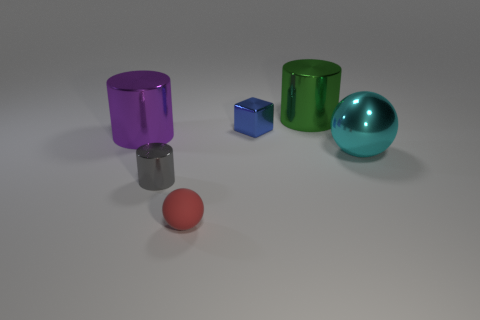Subtract all yellow spheres. Subtract all yellow blocks. How many spheres are left? 2 Add 4 purple cubes. How many objects exist? 10 Subtract all cubes. How many objects are left? 5 Subtract all big blue matte balls. Subtract all purple cylinders. How many objects are left? 5 Add 3 small gray objects. How many small gray objects are left? 4 Add 5 shiny spheres. How many shiny spheres exist? 6 Subtract 0 red cylinders. How many objects are left? 6 